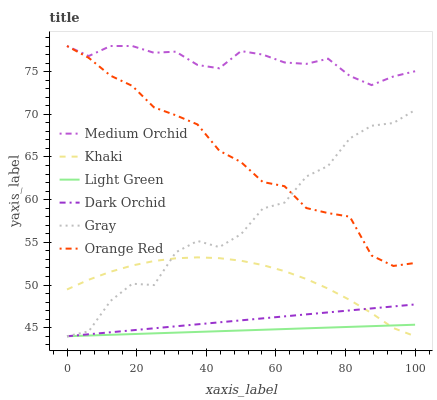Does Light Green have the minimum area under the curve?
Answer yes or no. Yes. Does Medium Orchid have the maximum area under the curve?
Answer yes or no. Yes. Does Khaki have the minimum area under the curve?
Answer yes or no. No. Does Khaki have the maximum area under the curve?
Answer yes or no. No. Is Dark Orchid the smoothest?
Answer yes or no. Yes. Is Gray the roughest?
Answer yes or no. Yes. Is Khaki the smoothest?
Answer yes or no. No. Is Khaki the roughest?
Answer yes or no. No. Does Gray have the lowest value?
Answer yes or no. Yes. Does Medium Orchid have the lowest value?
Answer yes or no. No. Does Orange Red have the highest value?
Answer yes or no. Yes. Does Khaki have the highest value?
Answer yes or no. No. Is Light Green less than Orange Red?
Answer yes or no. Yes. Is Orange Red greater than Light Green?
Answer yes or no. Yes. Does Orange Red intersect Gray?
Answer yes or no. Yes. Is Orange Red less than Gray?
Answer yes or no. No. Is Orange Red greater than Gray?
Answer yes or no. No. Does Light Green intersect Orange Red?
Answer yes or no. No. 